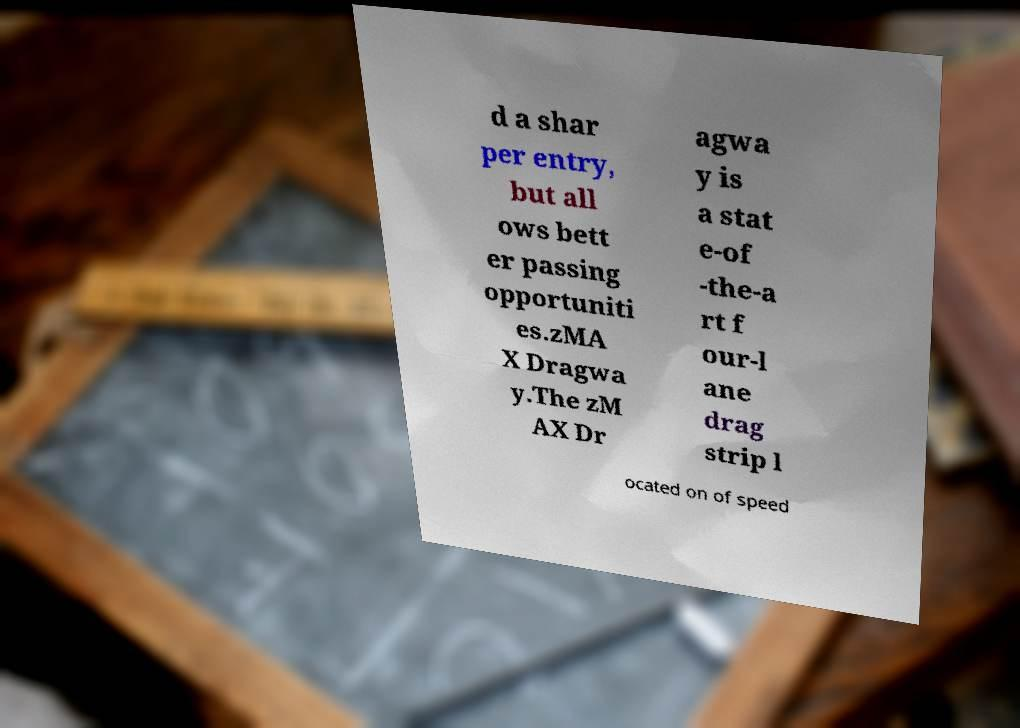Can you accurately transcribe the text from the provided image for me? d a shar per entry, but all ows bett er passing opportuniti es.zMA X Dragwa y.The zM AX Dr agwa y is a stat e-of -the-a rt f our-l ane drag strip l ocated on of speed 